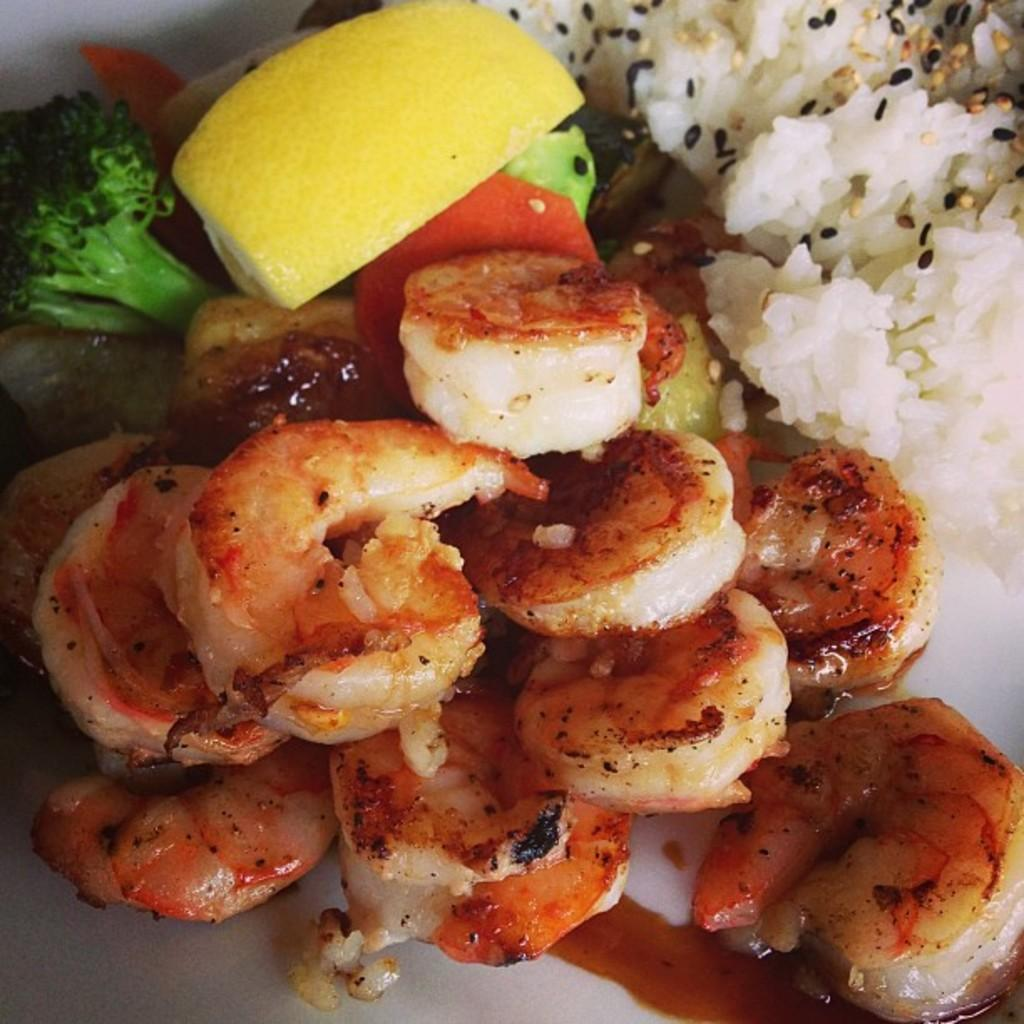What types of food items can be seen in the image? There are food items in the image, but the specific types cannot be determined from the provided facts. Can you identify any specific food item in the image? Yes, there is a piece of lemon in the image. What is the color of the surface the food items are placed on? The surface the items are on is white in color. What type of rock can be seen in the image? There is no rock present in the image. What is the flavor of the silverware in the image? There is no silverware present in the image. 